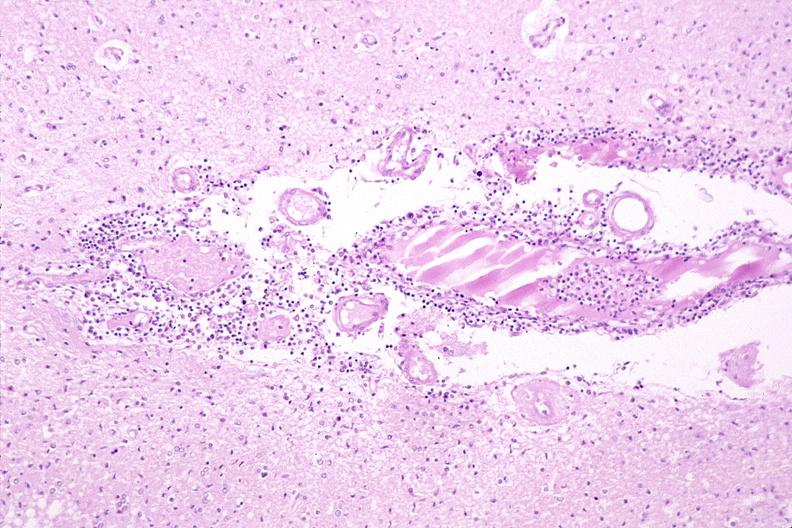s nervous present?
Answer the question using a single word or phrase. Yes 